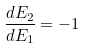<formula> <loc_0><loc_0><loc_500><loc_500>\frac { d E _ { 2 } } { d E _ { 1 } } = - 1</formula> 